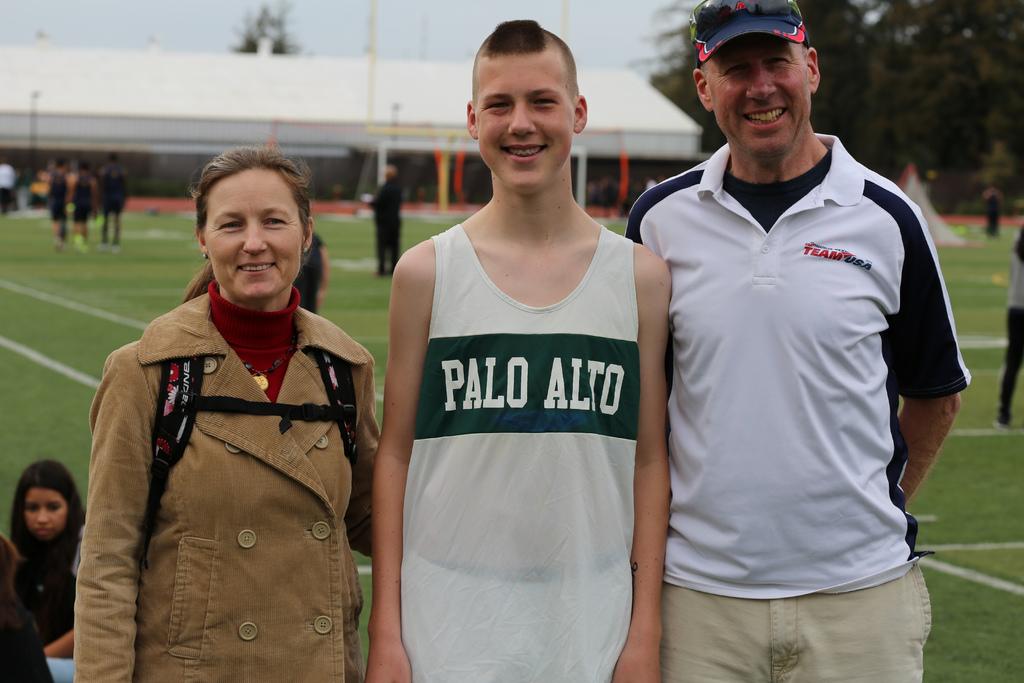What team does the boy run for?
Your answer should be compact. Palo alto. What is the brand on the older gentleman's shirt?
Offer a terse response. Team usa. 